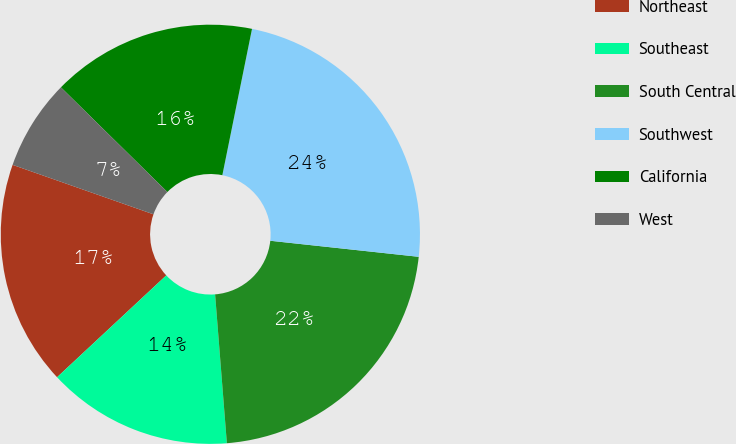Convert chart. <chart><loc_0><loc_0><loc_500><loc_500><pie_chart><fcel>Northeast<fcel>Southeast<fcel>South Central<fcel>Southwest<fcel>California<fcel>West<nl><fcel>17.32%<fcel>14.31%<fcel>22.03%<fcel>23.53%<fcel>15.82%<fcel>6.99%<nl></chart> 